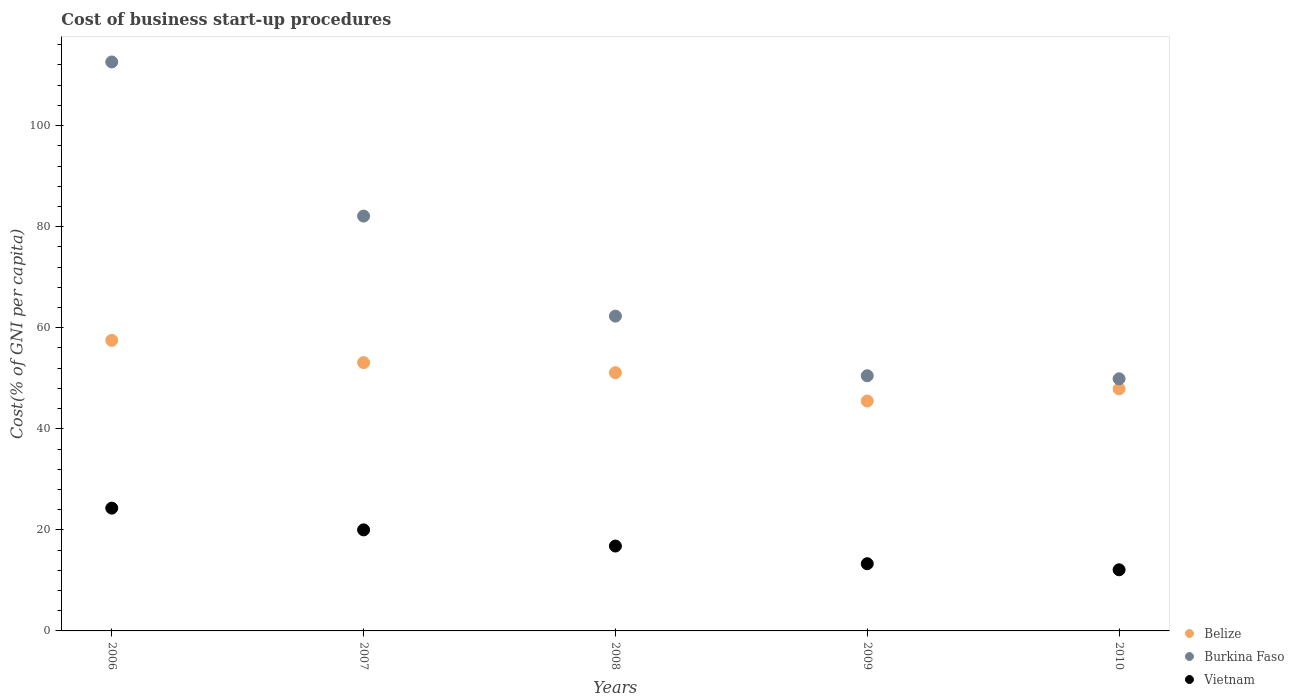How many different coloured dotlines are there?
Your response must be concise. 3. Is the number of dotlines equal to the number of legend labels?
Keep it short and to the point. Yes. What is the cost of business start-up procedures in Burkina Faso in 2009?
Your response must be concise. 50.5. Across all years, what is the maximum cost of business start-up procedures in Burkina Faso?
Make the answer very short. 112.6. Across all years, what is the minimum cost of business start-up procedures in Burkina Faso?
Make the answer very short. 49.9. In which year was the cost of business start-up procedures in Burkina Faso minimum?
Keep it short and to the point. 2010. What is the total cost of business start-up procedures in Burkina Faso in the graph?
Offer a very short reply. 357.4. What is the difference between the cost of business start-up procedures in Vietnam in 2007 and that in 2008?
Offer a very short reply. 3.2. What is the difference between the cost of business start-up procedures in Burkina Faso in 2010 and the cost of business start-up procedures in Belize in 2008?
Your answer should be compact. -1.2. What is the average cost of business start-up procedures in Belize per year?
Offer a terse response. 51.02. In the year 2006, what is the difference between the cost of business start-up procedures in Belize and cost of business start-up procedures in Burkina Faso?
Keep it short and to the point. -55.1. What is the ratio of the cost of business start-up procedures in Vietnam in 2009 to that in 2010?
Offer a terse response. 1.1. Is the difference between the cost of business start-up procedures in Belize in 2009 and 2010 greater than the difference between the cost of business start-up procedures in Burkina Faso in 2009 and 2010?
Your answer should be compact. No. What is the difference between the highest and the second highest cost of business start-up procedures in Vietnam?
Keep it short and to the point. 4.3. What is the difference between the highest and the lowest cost of business start-up procedures in Belize?
Your response must be concise. 12. In how many years, is the cost of business start-up procedures in Belize greater than the average cost of business start-up procedures in Belize taken over all years?
Give a very brief answer. 3. Is the sum of the cost of business start-up procedures in Burkina Faso in 2007 and 2010 greater than the maximum cost of business start-up procedures in Belize across all years?
Ensure brevity in your answer.  Yes. Does the cost of business start-up procedures in Belize monotonically increase over the years?
Your answer should be compact. No. How many dotlines are there?
Keep it short and to the point. 3. How many years are there in the graph?
Ensure brevity in your answer.  5. Where does the legend appear in the graph?
Offer a terse response. Bottom right. How many legend labels are there?
Provide a short and direct response. 3. What is the title of the graph?
Make the answer very short. Cost of business start-up procedures. What is the label or title of the X-axis?
Keep it short and to the point. Years. What is the label or title of the Y-axis?
Provide a short and direct response. Cost(% of GNI per capita). What is the Cost(% of GNI per capita) of Belize in 2006?
Offer a very short reply. 57.5. What is the Cost(% of GNI per capita) of Burkina Faso in 2006?
Give a very brief answer. 112.6. What is the Cost(% of GNI per capita) of Vietnam in 2006?
Give a very brief answer. 24.3. What is the Cost(% of GNI per capita) of Belize in 2007?
Your response must be concise. 53.1. What is the Cost(% of GNI per capita) of Burkina Faso in 2007?
Keep it short and to the point. 82.1. What is the Cost(% of GNI per capita) in Vietnam in 2007?
Provide a short and direct response. 20. What is the Cost(% of GNI per capita) in Belize in 2008?
Keep it short and to the point. 51.1. What is the Cost(% of GNI per capita) of Burkina Faso in 2008?
Your answer should be very brief. 62.3. What is the Cost(% of GNI per capita) of Belize in 2009?
Provide a short and direct response. 45.5. What is the Cost(% of GNI per capita) of Burkina Faso in 2009?
Provide a short and direct response. 50.5. What is the Cost(% of GNI per capita) of Belize in 2010?
Keep it short and to the point. 47.9. What is the Cost(% of GNI per capita) of Burkina Faso in 2010?
Your response must be concise. 49.9. What is the Cost(% of GNI per capita) in Vietnam in 2010?
Your answer should be compact. 12.1. Across all years, what is the maximum Cost(% of GNI per capita) in Belize?
Ensure brevity in your answer.  57.5. Across all years, what is the maximum Cost(% of GNI per capita) in Burkina Faso?
Provide a short and direct response. 112.6. Across all years, what is the maximum Cost(% of GNI per capita) of Vietnam?
Give a very brief answer. 24.3. Across all years, what is the minimum Cost(% of GNI per capita) of Belize?
Give a very brief answer. 45.5. Across all years, what is the minimum Cost(% of GNI per capita) of Burkina Faso?
Your answer should be compact. 49.9. Across all years, what is the minimum Cost(% of GNI per capita) of Vietnam?
Provide a succinct answer. 12.1. What is the total Cost(% of GNI per capita) of Belize in the graph?
Offer a very short reply. 255.1. What is the total Cost(% of GNI per capita) of Burkina Faso in the graph?
Give a very brief answer. 357.4. What is the total Cost(% of GNI per capita) of Vietnam in the graph?
Your answer should be very brief. 86.5. What is the difference between the Cost(% of GNI per capita) in Burkina Faso in 2006 and that in 2007?
Provide a short and direct response. 30.5. What is the difference between the Cost(% of GNI per capita) in Vietnam in 2006 and that in 2007?
Give a very brief answer. 4.3. What is the difference between the Cost(% of GNI per capita) of Burkina Faso in 2006 and that in 2008?
Make the answer very short. 50.3. What is the difference between the Cost(% of GNI per capita) of Burkina Faso in 2006 and that in 2009?
Give a very brief answer. 62.1. What is the difference between the Cost(% of GNI per capita) in Vietnam in 2006 and that in 2009?
Your answer should be very brief. 11. What is the difference between the Cost(% of GNI per capita) in Belize in 2006 and that in 2010?
Provide a short and direct response. 9.6. What is the difference between the Cost(% of GNI per capita) in Burkina Faso in 2006 and that in 2010?
Provide a short and direct response. 62.7. What is the difference between the Cost(% of GNI per capita) in Belize in 2007 and that in 2008?
Give a very brief answer. 2. What is the difference between the Cost(% of GNI per capita) of Burkina Faso in 2007 and that in 2008?
Your answer should be very brief. 19.8. What is the difference between the Cost(% of GNI per capita) in Burkina Faso in 2007 and that in 2009?
Offer a very short reply. 31.6. What is the difference between the Cost(% of GNI per capita) of Vietnam in 2007 and that in 2009?
Offer a terse response. 6.7. What is the difference between the Cost(% of GNI per capita) in Burkina Faso in 2007 and that in 2010?
Your response must be concise. 32.2. What is the difference between the Cost(% of GNI per capita) of Vietnam in 2007 and that in 2010?
Your response must be concise. 7.9. What is the difference between the Cost(% of GNI per capita) of Belize in 2008 and that in 2009?
Provide a succinct answer. 5.6. What is the difference between the Cost(% of GNI per capita) in Burkina Faso in 2008 and that in 2009?
Your response must be concise. 11.8. What is the difference between the Cost(% of GNI per capita) of Belize in 2008 and that in 2010?
Provide a succinct answer. 3.2. What is the difference between the Cost(% of GNI per capita) in Burkina Faso in 2008 and that in 2010?
Offer a terse response. 12.4. What is the difference between the Cost(% of GNI per capita) in Vietnam in 2008 and that in 2010?
Provide a short and direct response. 4.7. What is the difference between the Cost(% of GNI per capita) in Vietnam in 2009 and that in 2010?
Give a very brief answer. 1.2. What is the difference between the Cost(% of GNI per capita) of Belize in 2006 and the Cost(% of GNI per capita) of Burkina Faso in 2007?
Give a very brief answer. -24.6. What is the difference between the Cost(% of GNI per capita) in Belize in 2006 and the Cost(% of GNI per capita) in Vietnam in 2007?
Give a very brief answer. 37.5. What is the difference between the Cost(% of GNI per capita) in Burkina Faso in 2006 and the Cost(% of GNI per capita) in Vietnam in 2007?
Provide a succinct answer. 92.6. What is the difference between the Cost(% of GNI per capita) in Belize in 2006 and the Cost(% of GNI per capita) in Burkina Faso in 2008?
Your response must be concise. -4.8. What is the difference between the Cost(% of GNI per capita) in Belize in 2006 and the Cost(% of GNI per capita) in Vietnam in 2008?
Give a very brief answer. 40.7. What is the difference between the Cost(% of GNI per capita) of Burkina Faso in 2006 and the Cost(% of GNI per capita) of Vietnam in 2008?
Your response must be concise. 95.8. What is the difference between the Cost(% of GNI per capita) of Belize in 2006 and the Cost(% of GNI per capita) of Burkina Faso in 2009?
Your answer should be very brief. 7. What is the difference between the Cost(% of GNI per capita) in Belize in 2006 and the Cost(% of GNI per capita) in Vietnam in 2009?
Give a very brief answer. 44.2. What is the difference between the Cost(% of GNI per capita) in Burkina Faso in 2006 and the Cost(% of GNI per capita) in Vietnam in 2009?
Keep it short and to the point. 99.3. What is the difference between the Cost(% of GNI per capita) of Belize in 2006 and the Cost(% of GNI per capita) of Burkina Faso in 2010?
Offer a terse response. 7.6. What is the difference between the Cost(% of GNI per capita) in Belize in 2006 and the Cost(% of GNI per capita) in Vietnam in 2010?
Give a very brief answer. 45.4. What is the difference between the Cost(% of GNI per capita) in Burkina Faso in 2006 and the Cost(% of GNI per capita) in Vietnam in 2010?
Your answer should be compact. 100.5. What is the difference between the Cost(% of GNI per capita) of Belize in 2007 and the Cost(% of GNI per capita) of Burkina Faso in 2008?
Offer a terse response. -9.2. What is the difference between the Cost(% of GNI per capita) of Belize in 2007 and the Cost(% of GNI per capita) of Vietnam in 2008?
Ensure brevity in your answer.  36.3. What is the difference between the Cost(% of GNI per capita) in Burkina Faso in 2007 and the Cost(% of GNI per capita) in Vietnam in 2008?
Offer a very short reply. 65.3. What is the difference between the Cost(% of GNI per capita) in Belize in 2007 and the Cost(% of GNI per capita) in Vietnam in 2009?
Offer a very short reply. 39.8. What is the difference between the Cost(% of GNI per capita) in Burkina Faso in 2007 and the Cost(% of GNI per capita) in Vietnam in 2009?
Give a very brief answer. 68.8. What is the difference between the Cost(% of GNI per capita) of Belize in 2007 and the Cost(% of GNI per capita) of Burkina Faso in 2010?
Offer a terse response. 3.2. What is the difference between the Cost(% of GNI per capita) in Burkina Faso in 2007 and the Cost(% of GNI per capita) in Vietnam in 2010?
Your response must be concise. 70. What is the difference between the Cost(% of GNI per capita) of Belize in 2008 and the Cost(% of GNI per capita) of Burkina Faso in 2009?
Make the answer very short. 0.6. What is the difference between the Cost(% of GNI per capita) in Belize in 2008 and the Cost(% of GNI per capita) in Vietnam in 2009?
Provide a short and direct response. 37.8. What is the difference between the Cost(% of GNI per capita) in Burkina Faso in 2008 and the Cost(% of GNI per capita) in Vietnam in 2009?
Your response must be concise. 49. What is the difference between the Cost(% of GNI per capita) in Burkina Faso in 2008 and the Cost(% of GNI per capita) in Vietnam in 2010?
Make the answer very short. 50.2. What is the difference between the Cost(% of GNI per capita) of Belize in 2009 and the Cost(% of GNI per capita) of Burkina Faso in 2010?
Your answer should be compact. -4.4. What is the difference between the Cost(% of GNI per capita) in Belize in 2009 and the Cost(% of GNI per capita) in Vietnam in 2010?
Your answer should be very brief. 33.4. What is the difference between the Cost(% of GNI per capita) of Burkina Faso in 2009 and the Cost(% of GNI per capita) of Vietnam in 2010?
Offer a very short reply. 38.4. What is the average Cost(% of GNI per capita) in Belize per year?
Provide a short and direct response. 51.02. What is the average Cost(% of GNI per capita) in Burkina Faso per year?
Give a very brief answer. 71.48. In the year 2006, what is the difference between the Cost(% of GNI per capita) of Belize and Cost(% of GNI per capita) of Burkina Faso?
Your answer should be very brief. -55.1. In the year 2006, what is the difference between the Cost(% of GNI per capita) in Belize and Cost(% of GNI per capita) in Vietnam?
Ensure brevity in your answer.  33.2. In the year 2006, what is the difference between the Cost(% of GNI per capita) of Burkina Faso and Cost(% of GNI per capita) of Vietnam?
Keep it short and to the point. 88.3. In the year 2007, what is the difference between the Cost(% of GNI per capita) in Belize and Cost(% of GNI per capita) in Burkina Faso?
Offer a terse response. -29. In the year 2007, what is the difference between the Cost(% of GNI per capita) of Belize and Cost(% of GNI per capita) of Vietnam?
Offer a terse response. 33.1. In the year 2007, what is the difference between the Cost(% of GNI per capita) of Burkina Faso and Cost(% of GNI per capita) of Vietnam?
Offer a terse response. 62.1. In the year 2008, what is the difference between the Cost(% of GNI per capita) of Belize and Cost(% of GNI per capita) of Vietnam?
Ensure brevity in your answer.  34.3. In the year 2008, what is the difference between the Cost(% of GNI per capita) in Burkina Faso and Cost(% of GNI per capita) in Vietnam?
Your answer should be very brief. 45.5. In the year 2009, what is the difference between the Cost(% of GNI per capita) in Belize and Cost(% of GNI per capita) in Burkina Faso?
Your answer should be compact. -5. In the year 2009, what is the difference between the Cost(% of GNI per capita) of Belize and Cost(% of GNI per capita) of Vietnam?
Your answer should be very brief. 32.2. In the year 2009, what is the difference between the Cost(% of GNI per capita) in Burkina Faso and Cost(% of GNI per capita) in Vietnam?
Offer a terse response. 37.2. In the year 2010, what is the difference between the Cost(% of GNI per capita) of Belize and Cost(% of GNI per capita) of Vietnam?
Keep it short and to the point. 35.8. In the year 2010, what is the difference between the Cost(% of GNI per capita) of Burkina Faso and Cost(% of GNI per capita) of Vietnam?
Your response must be concise. 37.8. What is the ratio of the Cost(% of GNI per capita) of Belize in 2006 to that in 2007?
Ensure brevity in your answer.  1.08. What is the ratio of the Cost(% of GNI per capita) in Burkina Faso in 2006 to that in 2007?
Your answer should be compact. 1.37. What is the ratio of the Cost(% of GNI per capita) in Vietnam in 2006 to that in 2007?
Ensure brevity in your answer.  1.22. What is the ratio of the Cost(% of GNI per capita) in Belize in 2006 to that in 2008?
Offer a terse response. 1.13. What is the ratio of the Cost(% of GNI per capita) in Burkina Faso in 2006 to that in 2008?
Provide a short and direct response. 1.81. What is the ratio of the Cost(% of GNI per capita) of Vietnam in 2006 to that in 2008?
Ensure brevity in your answer.  1.45. What is the ratio of the Cost(% of GNI per capita) of Belize in 2006 to that in 2009?
Your answer should be compact. 1.26. What is the ratio of the Cost(% of GNI per capita) of Burkina Faso in 2006 to that in 2009?
Your response must be concise. 2.23. What is the ratio of the Cost(% of GNI per capita) of Vietnam in 2006 to that in 2009?
Provide a succinct answer. 1.83. What is the ratio of the Cost(% of GNI per capita) of Belize in 2006 to that in 2010?
Your response must be concise. 1.2. What is the ratio of the Cost(% of GNI per capita) in Burkina Faso in 2006 to that in 2010?
Your answer should be very brief. 2.26. What is the ratio of the Cost(% of GNI per capita) of Vietnam in 2006 to that in 2010?
Your response must be concise. 2.01. What is the ratio of the Cost(% of GNI per capita) in Belize in 2007 to that in 2008?
Your answer should be very brief. 1.04. What is the ratio of the Cost(% of GNI per capita) of Burkina Faso in 2007 to that in 2008?
Your answer should be very brief. 1.32. What is the ratio of the Cost(% of GNI per capita) of Vietnam in 2007 to that in 2008?
Keep it short and to the point. 1.19. What is the ratio of the Cost(% of GNI per capita) of Belize in 2007 to that in 2009?
Your response must be concise. 1.17. What is the ratio of the Cost(% of GNI per capita) of Burkina Faso in 2007 to that in 2009?
Give a very brief answer. 1.63. What is the ratio of the Cost(% of GNI per capita) of Vietnam in 2007 to that in 2009?
Make the answer very short. 1.5. What is the ratio of the Cost(% of GNI per capita) of Belize in 2007 to that in 2010?
Ensure brevity in your answer.  1.11. What is the ratio of the Cost(% of GNI per capita) in Burkina Faso in 2007 to that in 2010?
Make the answer very short. 1.65. What is the ratio of the Cost(% of GNI per capita) in Vietnam in 2007 to that in 2010?
Provide a short and direct response. 1.65. What is the ratio of the Cost(% of GNI per capita) in Belize in 2008 to that in 2009?
Provide a succinct answer. 1.12. What is the ratio of the Cost(% of GNI per capita) of Burkina Faso in 2008 to that in 2009?
Your answer should be compact. 1.23. What is the ratio of the Cost(% of GNI per capita) of Vietnam in 2008 to that in 2009?
Your answer should be very brief. 1.26. What is the ratio of the Cost(% of GNI per capita) in Belize in 2008 to that in 2010?
Offer a very short reply. 1.07. What is the ratio of the Cost(% of GNI per capita) in Burkina Faso in 2008 to that in 2010?
Keep it short and to the point. 1.25. What is the ratio of the Cost(% of GNI per capita) in Vietnam in 2008 to that in 2010?
Your response must be concise. 1.39. What is the ratio of the Cost(% of GNI per capita) in Belize in 2009 to that in 2010?
Ensure brevity in your answer.  0.95. What is the ratio of the Cost(% of GNI per capita) of Burkina Faso in 2009 to that in 2010?
Your answer should be compact. 1.01. What is the ratio of the Cost(% of GNI per capita) in Vietnam in 2009 to that in 2010?
Offer a terse response. 1.1. What is the difference between the highest and the second highest Cost(% of GNI per capita) of Belize?
Keep it short and to the point. 4.4. What is the difference between the highest and the second highest Cost(% of GNI per capita) of Burkina Faso?
Keep it short and to the point. 30.5. What is the difference between the highest and the second highest Cost(% of GNI per capita) of Vietnam?
Provide a succinct answer. 4.3. What is the difference between the highest and the lowest Cost(% of GNI per capita) of Burkina Faso?
Make the answer very short. 62.7. 